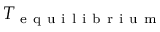<formula> <loc_0><loc_0><loc_500><loc_500>T _ { e q u i l i b r i u m }</formula> 